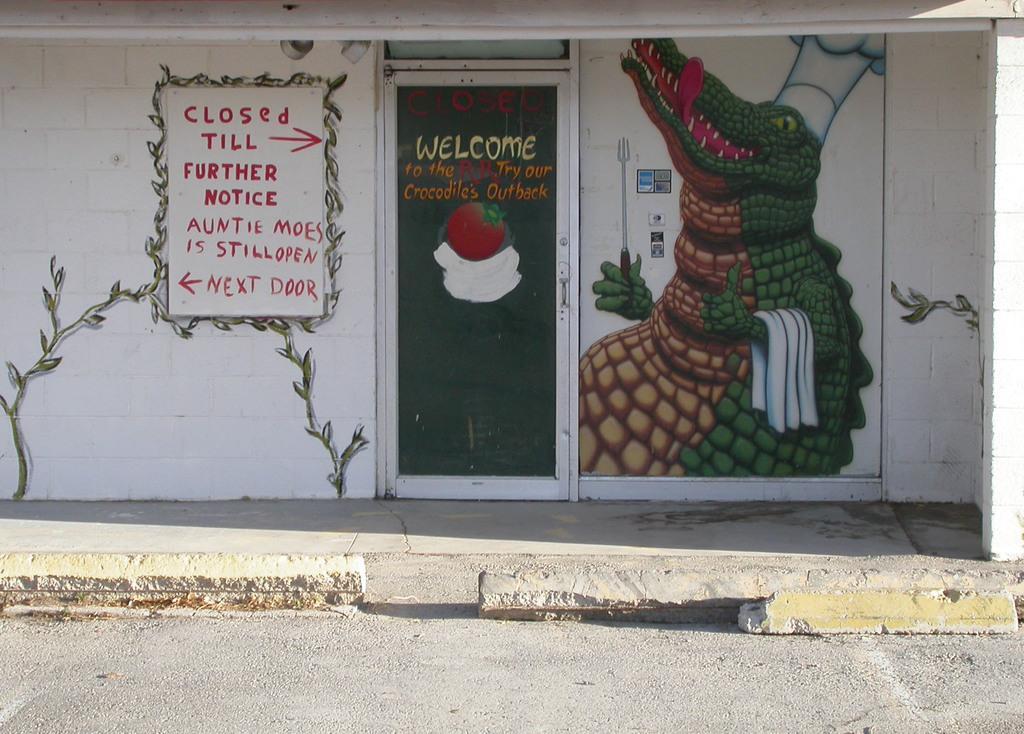In one or two sentences, can you explain what this image depicts? This is an outside view. At the bottom there is a road. In the background there a door to the wall. On the wall, I can see some paintings and text. 